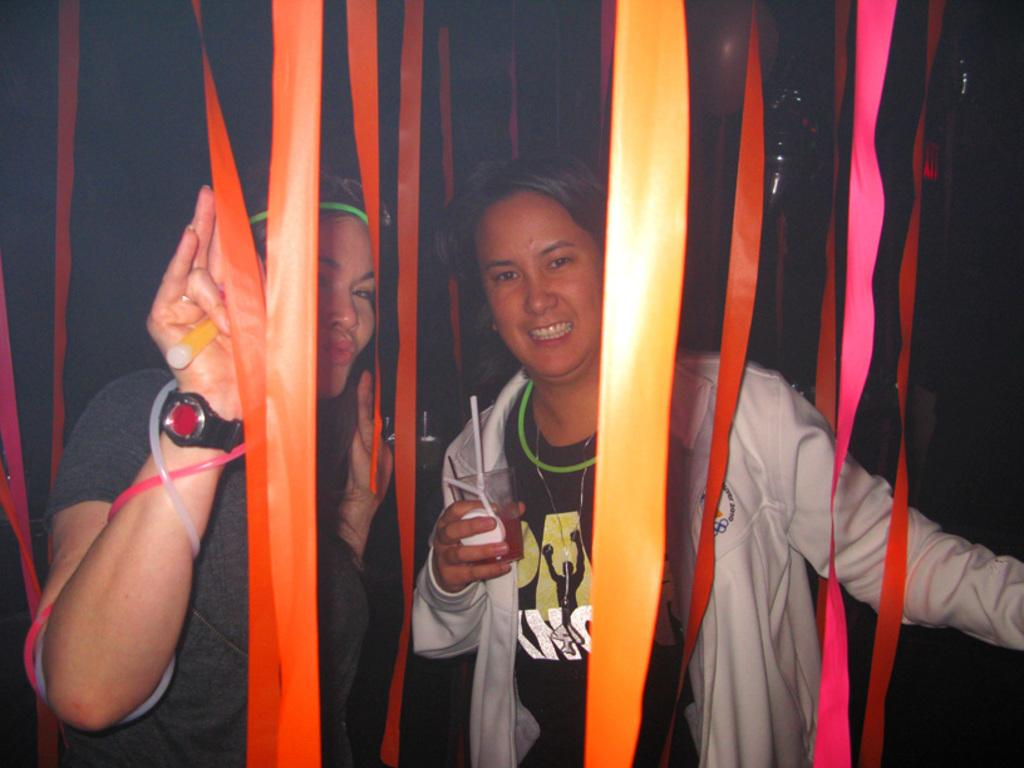Who is present in the image? There is a woman in the image. What is the woman holding in the image? The woman is holding a glass. What other objects can be seen in the image? There are ribbons in the image. How many partners does the woman have in the image? There is no indication of a partner in the image; it only features a woman holding a glass and ribbons. What type of wine is being served in the glass? There is no wine present in the image; the woman is holding a glass, but the contents are not specified. 